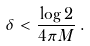Convert formula to latex. <formula><loc_0><loc_0><loc_500><loc_500>\delta < \frac { \log 2 } { 4 \pi M } \, .</formula> 